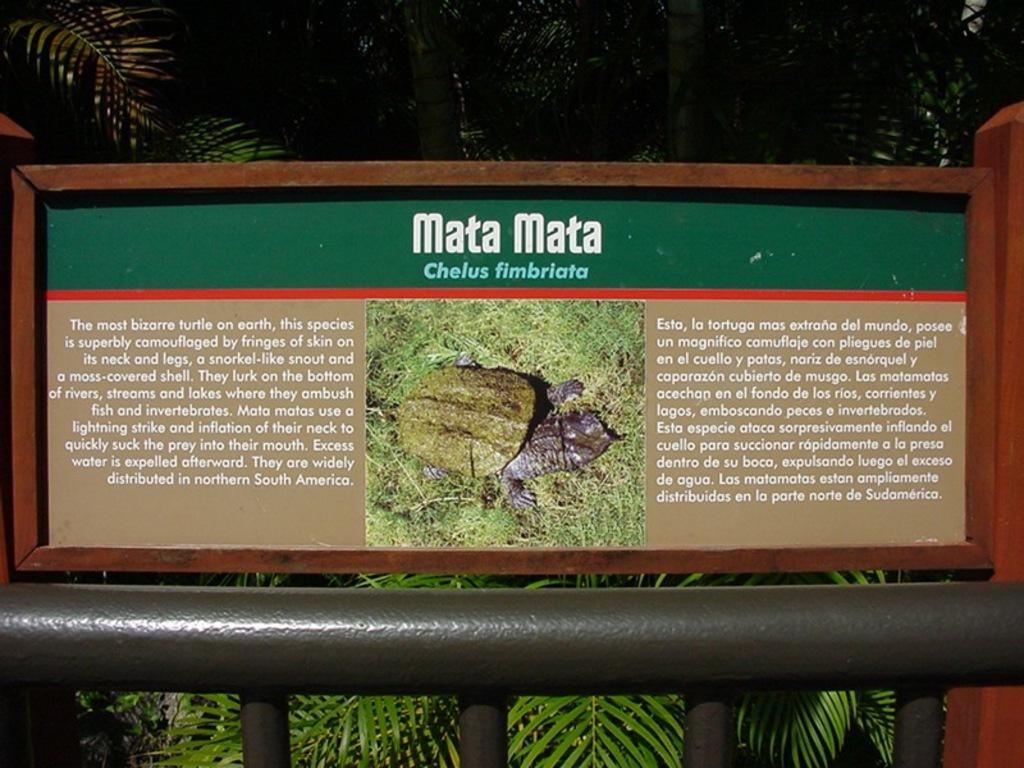What is the main object in the center of the image? There is a board in the center of the image. What is written or depicted on the board? There is text on the board. What can be seen at the bottom of the image? There is a fence at the bottom of the image. What type of natural scenery is visible in the background? There are trees in the background of the image. What type of teeth can be seen on the board in the image? There are no teeth present on the board or in the image. 